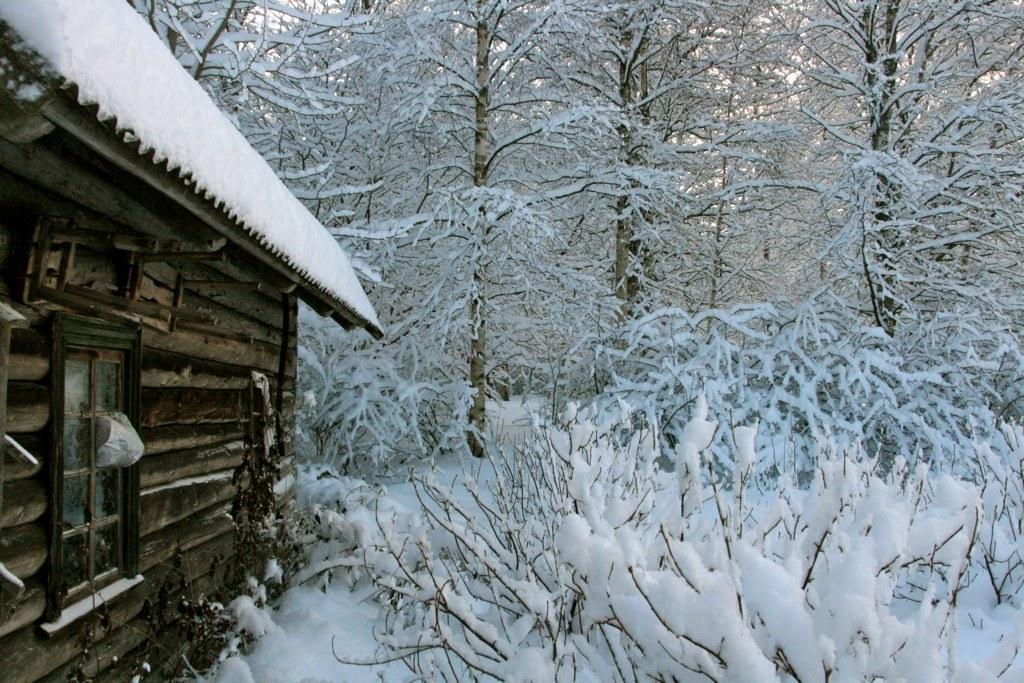How would you summarize this image in a sentence or two? In this picture we can see one house and some trees covered with snow. 